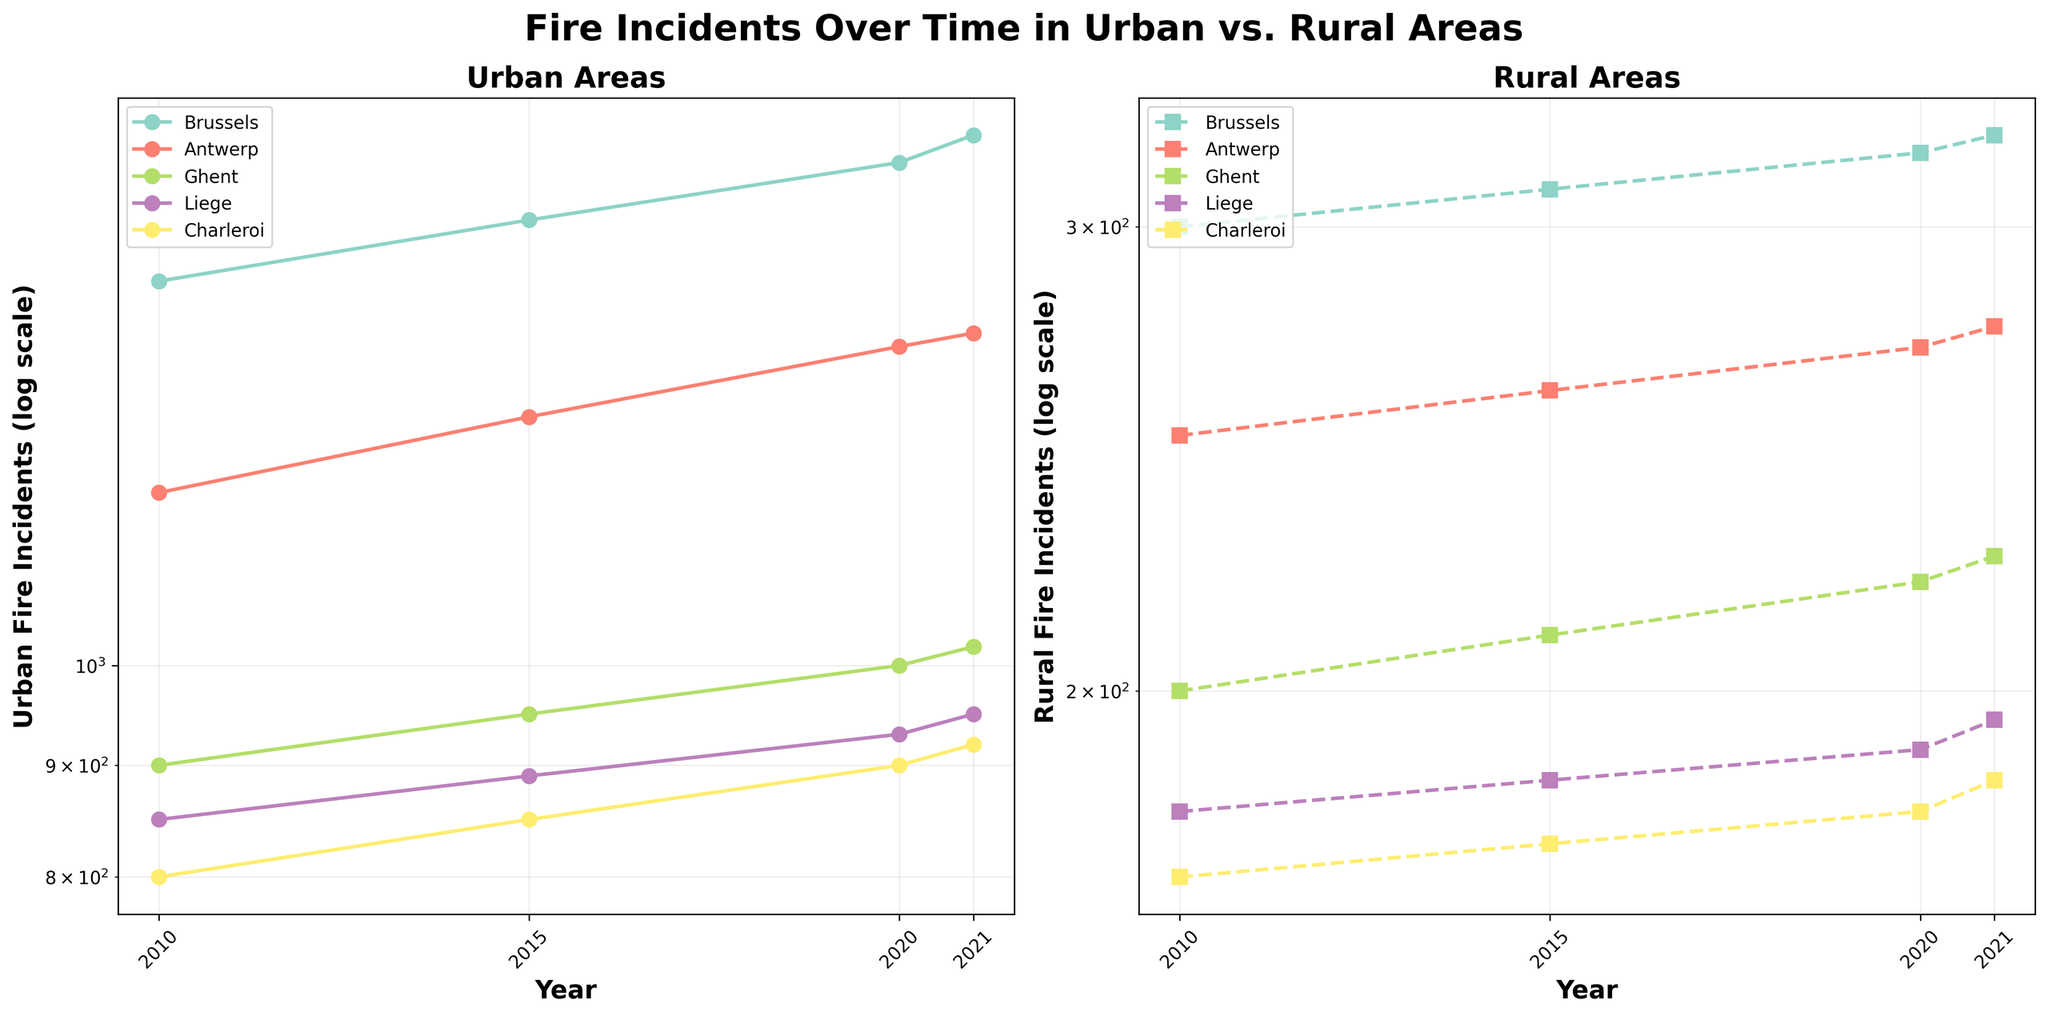What is the title of the figure? The title is displayed at the top of the figure and summarizes the content, which in this case is "Fire Incidents Over Time in Urban vs. Rural Areas."
Answer: Fire Incidents Over Time in Urban vs. Rural Areas Which location had the most urban fire incidents in 2021? In the urban subplot, look for the year 2021, then identify the location line that reaches the highest point on the y-axis. Brussels had the most urban fire incidents in 2021.
Answer: Brussels What is the scale of the y-axis in both subplots? Both subplots have a log scale on the y-axis, as indicated by the "log scale" label and the spacing of the tick marks.
Answer: Log scale By how much did the number of rural fire incidents in Ghent increase from 2010 to 2021? Find the data for Ghent in the rural subplot at the years 2010 and 2021, then calculate the difference (225 - 200).
Answer: 25 How do rural fire incidents in Charleroi compare between 2010 and 2021? In the rural subplot, locate the points for Charleroi in the years 2010 and 2021 and compare their y-values to determine the change. The incidents increased from 170 to 185.
Answer: Increased by 15 Which subplot shows more variation in fire incidents over the years? Compare the range and fluctuation of lines in both subplots. The urban subplot shows a higher variation with larger data ranges.
Answer: Urban subplot How does the trend of urban fire incidents in Antwerp compare to those in Brussels from 2010 to 2021? In the urban subplot, compare the lines for Antwerp and Brussels over the years. Both show an increasing trend, but Brussels consistently has higher incidents.
Answer: Brussels has higher incidents, but both are increasing How has the number of rural fire incidents in Liege changed from 2010 to 2021? Identify the points for Liege in the rural subplot at years 2010 and 2021, noting the change in y-values. Incidents increased from 180 to 195.
Answer: Increased by 15 What is the trend for urban fire incidents in Ghent from 2010 to 2021? Trace the line for Ghent in the urban subplot and note the overall direction (increase or decrease) of the y-values over the years. The trend shows an increase.
Answer: Increasing trend Which area, urban or rural, generally has higher fire incident numbers? Compare the overall y-values of both subplots. Urban areas generally show higher fire incident numbers compared to rural areas.
Answer: Urban areas 